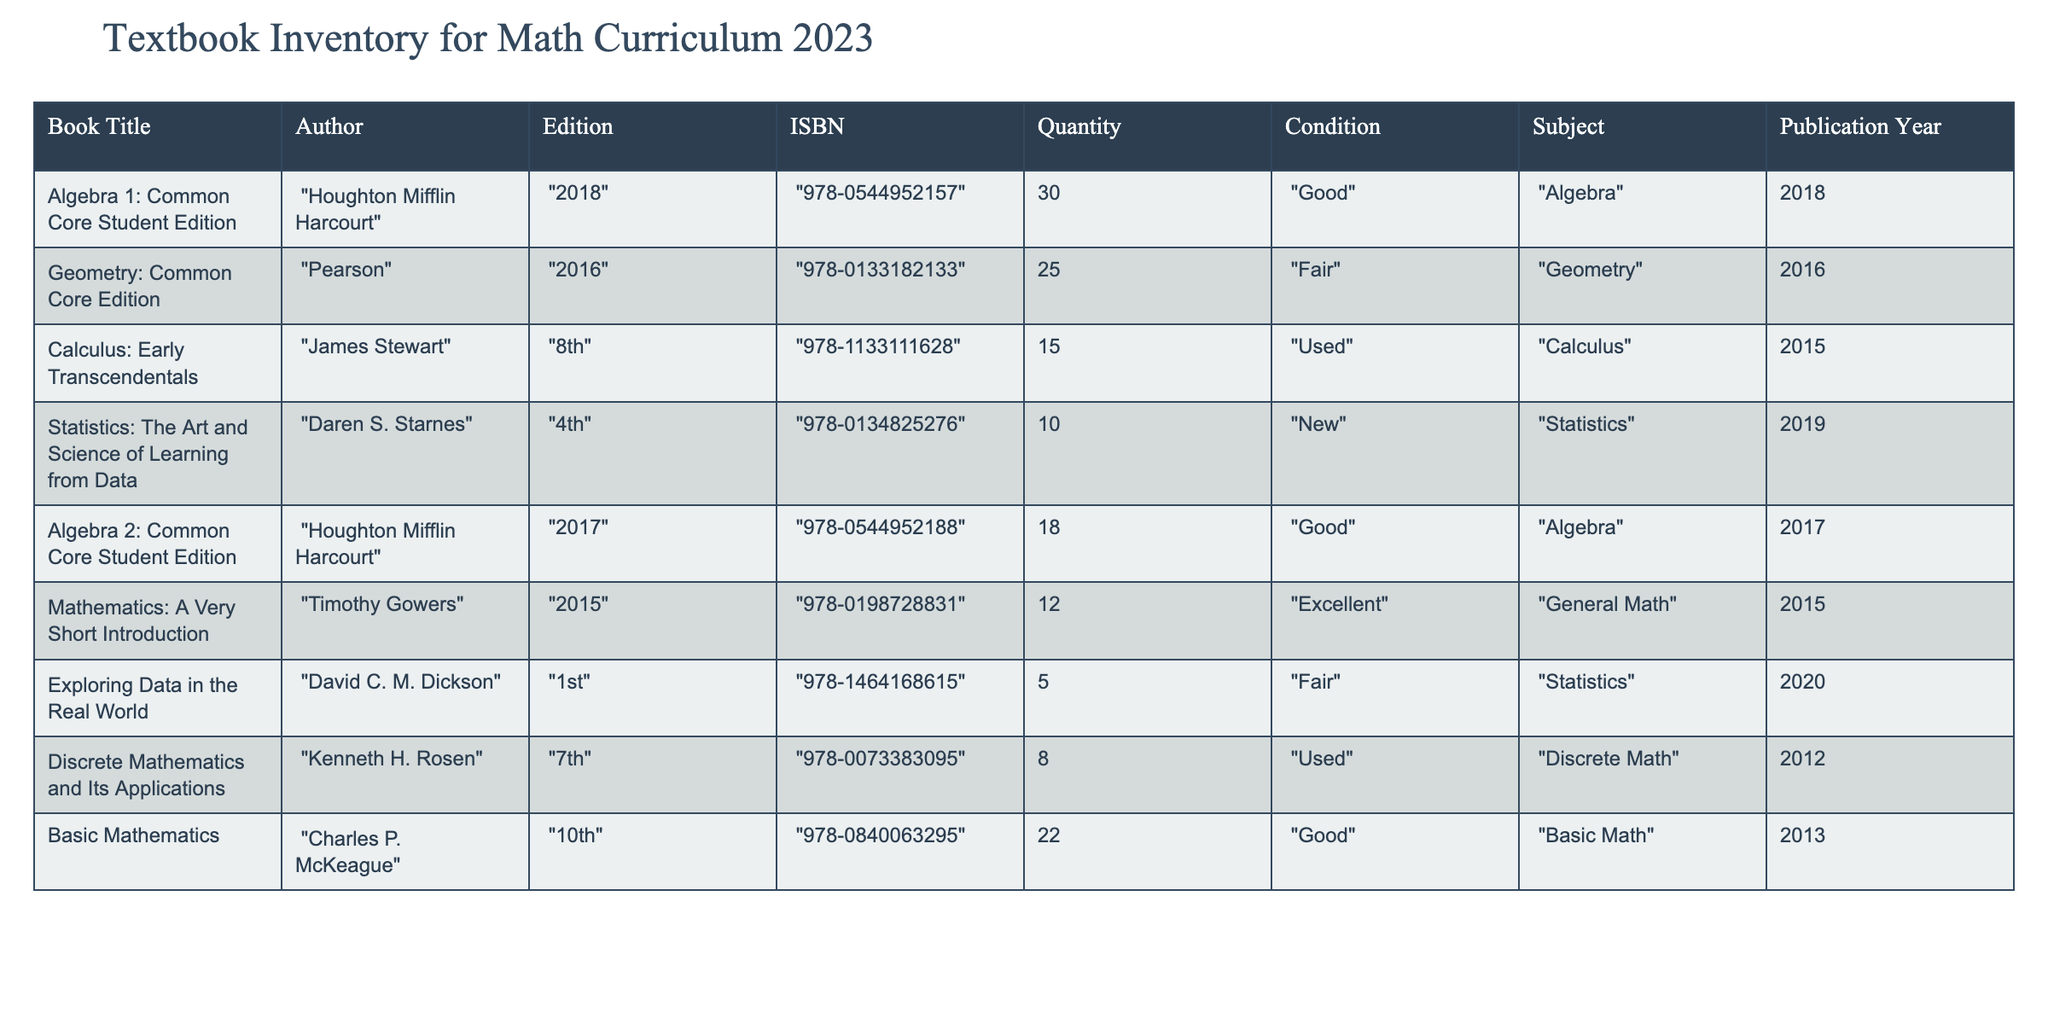What is the total quantity of "Calculus: Early Transcendentals" available? The quantity of "Calculus: Early Transcendentals" is located in the Quantity column next to its title. The value listed is 15.
Answer: 15 Which book has the highest quantity available? To find the highest quantity, we can compare the Quantity column values: Algebra 1 has 30, Algebra 2 has 18, and all others have less than 30. Therefore, "Algebra 1: Common Core Student Edition" has the highest quantity of 30.
Answer: Algebra 1: Common Core Student Edition Is there any book listed under "Statistics" that is in "New" condition? Looking in the Condition column for "Statistics" subject entries, "Statistics: The Art and Science of Learning from Data" is listed and it is in "New" condition.
Answer: Yes What is the average publication year of the textbooks listed? To calculate the average, add the publication years: (2018 + 2016 + 2015 + 2019 + 2017 + 2015 + 2020 + 2012 + 2013) = 1815. There are 9 books, so the average is 1815/9 = 201.67, rounding gives us the average year as 2016.
Answer: 2016 How many books in the inventory are in "Used" condition? The books listed as "Used" are "Calculus: Early Transcendentals" and "Discrete Mathematics and Its Applications." Counting these gives us a total of 2 books in used condition.
Answer: 2 Which book has the least quantity available? By looking through the Quantity column, "Exploring Data in the Real World" has the least quantity with a value of 5, while all others have more.
Answer: Exploring Data in the Real World Are there any Algebra textbooks published after 2015? Checking the titles under the Algebra subject category reveals "Algebra 1: Common Core Student Edition" (2018) and "Algebra 2: Common Core Student Edition" (2017) are both published after 2015.
Answer: Yes If we consider only the "Good" condition books, what is the total quantity? The books in "Good" condition are "Algebra 1: Common Core Student Edition" (30), "Algebra 2: Common Core Student Edition" (18), and "Basic Mathematics" (22). Adding these gives 30 + 18 + 22 = 70.
Answer: 70 What is the condition of the book "Discrete Mathematics and Its Applications"? By locating "Discrete Mathematics and Its Applications" in the Condition column, we see it is listed as "Used".
Answer: Used 